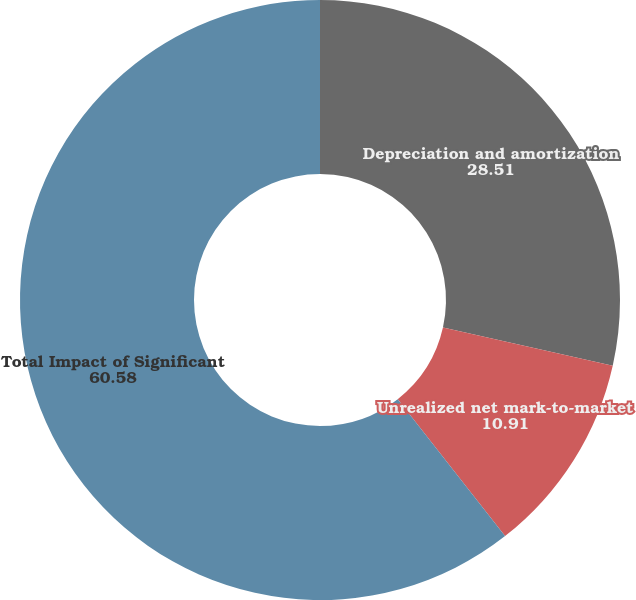<chart> <loc_0><loc_0><loc_500><loc_500><pie_chart><fcel>Depreciation and amortization<fcel>Unrealized net mark-to-market<fcel>Total Impact of Significant<nl><fcel>28.51%<fcel>10.91%<fcel>60.58%<nl></chart> 